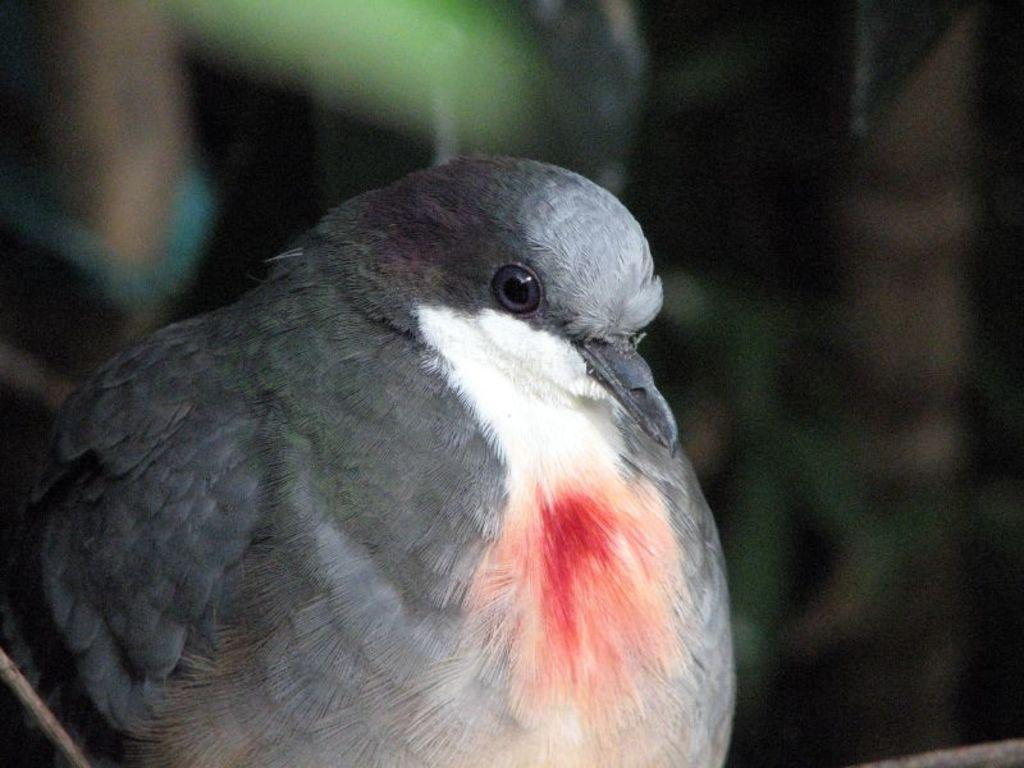What is the main subject in the foreground of the image? There is a bird in the foreground of the image. What is the bird doing in the image? The bird seems to be sitting. Can you describe the background of the image? The background of the image is blurry. What type of potato is being used to print the bird's image in the picture? There is no potato or printing process present in the image; it is a photograph of a bird sitting in the foreground. 